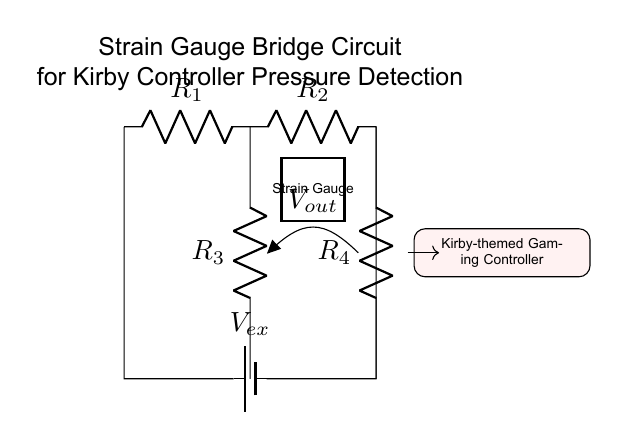What is the configuration of the circuit? The circuit diagram depicts a Wheatstone bridge configuration, where resistors are arranged in a diamond shape with a voltage measurement across one of the diagonal connections.
Answer: Wheatstone bridge How many resistors are in the circuit? There are four resistors labeled R1, R2, R3, and R4 in the circuit diagram.
Answer: Four What is the purpose of the strain gauge in this circuit? The strain gauge is used to measure deformation or strain due to pressure, which affects its resistance and thereby shifts the voltage output.
Answer: Measure pressure What is the output voltage measurement point labeled as? The output voltage measurement point is labeled as Vout, which indicates where the voltage is measured between the two paths of the bridge circuit.
Answer: Vout Why is the strain gauge significant in this controller? The strain gauge is crucial for detecting pressure changes, allowing the controller to respond to user input, enhancing gameplay interaction.
Answer: Detect pressure changes What does the power source in the circuit provide? The power source, indicated as Vex, provides the necessary voltage to energize the circuit and facilitate current flow through the resistors, which is essential for operation.
Answer: Voltage supply 